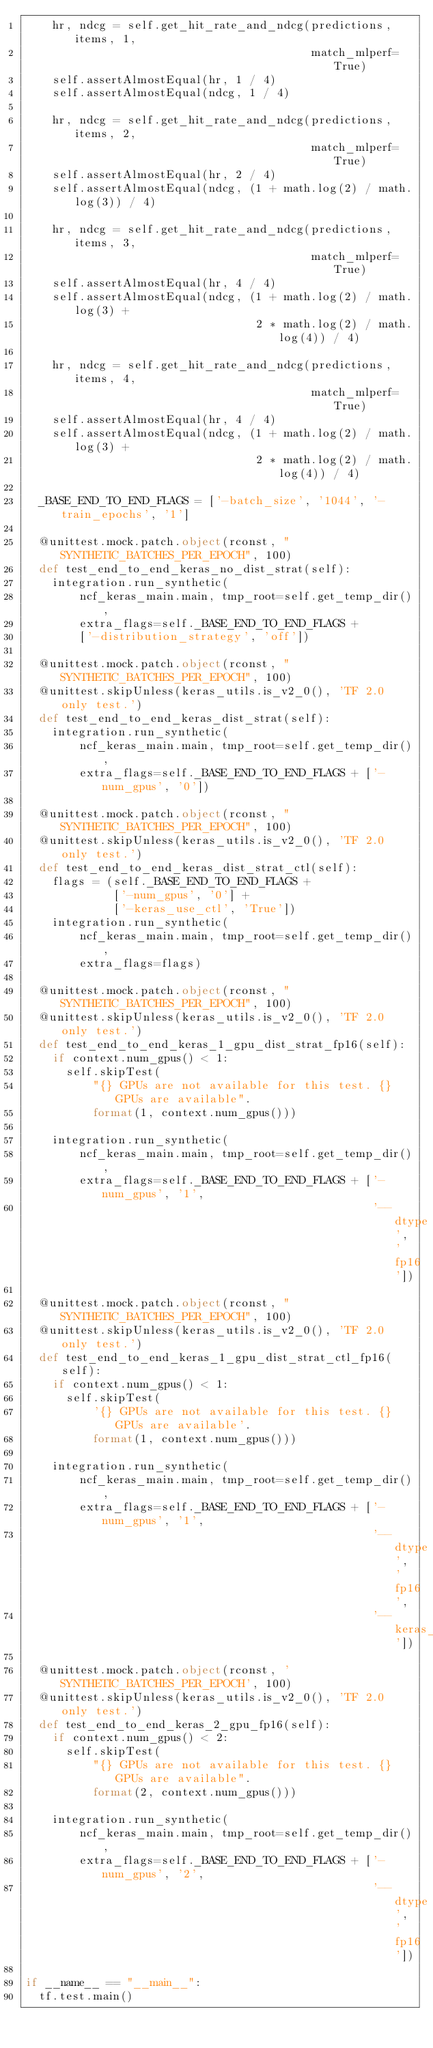Convert code to text. <code><loc_0><loc_0><loc_500><loc_500><_Python_>    hr, ndcg = self.get_hit_rate_and_ndcg(predictions, items, 1,
                                          match_mlperf=True)
    self.assertAlmostEqual(hr, 1 / 4)
    self.assertAlmostEqual(ndcg, 1 / 4)

    hr, ndcg = self.get_hit_rate_and_ndcg(predictions, items, 2,
                                          match_mlperf=True)
    self.assertAlmostEqual(hr, 2 / 4)
    self.assertAlmostEqual(ndcg, (1 + math.log(2) / math.log(3)) / 4)

    hr, ndcg = self.get_hit_rate_and_ndcg(predictions, items, 3,
                                          match_mlperf=True)
    self.assertAlmostEqual(hr, 4 / 4)
    self.assertAlmostEqual(ndcg, (1 + math.log(2) / math.log(3) +
                                  2 * math.log(2) / math.log(4)) / 4)

    hr, ndcg = self.get_hit_rate_and_ndcg(predictions, items, 4,
                                          match_mlperf=True)
    self.assertAlmostEqual(hr, 4 / 4)
    self.assertAlmostEqual(ndcg, (1 + math.log(2) / math.log(3) +
                                  2 * math.log(2) / math.log(4)) / 4)

  _BASE_END_TO_END_FLAGS = ['-batch_size', '1044', '-train_epochs', '1']

  @unittest.mock.patch.object(rconst, "SYNTHETIC_BATCHES_PER_EPOCH", 100)
  def test_end_to_end_keras_no_dist_strat(self):
    integration.run_synthetic(
        ncf_keras_main.main, tmp_root=self.get_temp_dir(),
        extra_flags=self._BASE_END_TO_END_FLAGS +
        ['-distribution_strategy', 'off'])

  @unittest.mock.patch.object(rconst, "SYNTHETIC_BATCHES_PER_EPOCH", 100)
  @unittest.skipUnless(keras_utils.is_v2_0(), 'TF 2.0 only test.')
  def test_end_to_end_keras_dist_strat(self):
    integration.run_synthetic(
        ncf_keras_main.main, tmp_root=self.get_temp_dir(),
        extra_flags=self._BASE_END_TO_END_FLAGS + ['-num_gpus', '0'])

  @unittest.mock.patch.object(rconst, "SYNTHETIC_BATCHES_PER_EPOCH", 100)
  @unittest.skipUnless(keras_utils.is_v2_0(), 'TF 2.0 only test.')
  def test_end_to_end_keras_dist_strat_ctl(self):
    flags = (self._BASE_END_TO_END_FLAGS +
             ['-num_gpus', '0'] +
             ['-keras_use_ctl', 'True'])
    integration.run_synthetic(
        ncf_keras_main.main, tmp_root=self.get_temp_dir(),
        extra_flags=flags)

  @unittest.mock.patch.object(rconst, "SYNTHETIC_BATCHES_PER_EPOCH", 100)
  @unittest.skipUnless(keras_utils.is_v2_0(), 'TF 2.0 only test.')
  def test_end_to_end_keras_1_gpu_dist_strat_fp16(self):
    if context.num_gpus() < 1:
      self.skipTest(
          "{} GPUs are not available for this test. {} GPUs are available".
          format(1, context.num_gpus()))

    integration.run_synthetic(
        ncf_keras_main.main, tmp_root=self.get_temp_dir(),
        extra_flags=self._BASE_END_TO_END_FLAGS + ['-num_gpus', '1',
                                                   '--dtype', 'fp16'])

  @unittest.mock.patch.object(rconst, "SYNTHETIC_BATCHES_PER_EPOCH", 100)
  @unittest.skipUnless(keras_utils.is_v2_0(), 'TF 2.0 only test.')
  def test_end_to_end_keras_1_gpu_dist_strat_ctl_fp16(self):
    if context.num_gpus() < 1:
      self.skipTest(
          '{} GPUs are not available for this test. {} GPUs are available'.
          format(1, context.num_gpus()))

    integration.run_synthetic(
        ncf_keras_main.main, tmp_root=self.get_temp_dir(),
        extra_flags=self._BASE_END_TO_END_FLAGS + ['-num_gpus', '1',
                                                   '--dtype', 'fp16',
                                                   '--keras_use_ctl'])

  @unittest.mock.patch.object(rconst, 'SYNTHETIC_BATCHES_PER_EPOCH', 100)
  @unittest.skipUnless(keras_utils.is_v2_0(), 'TF 2.0 only test.')
  def test_end_to_end_keras_2_gpu_fp16(self):
    if context.num_gpus() < 2:
      self.skipTest(
          "{} GPUs are not available for this test. {} GPUs are available".
          format(2, context.num_gpus()))

    integration.run_synthetic(
        ncf_keras_main.main, tmp_root=self.get_temp_dir(),
        extra_flags=self._BASE_END_TO_END_FLAGS + ['-num_gpus', '2',
                                                   '--dtype', 'fp16'])

if __name__ == "__main__":
  tf.test.main()
</code> 